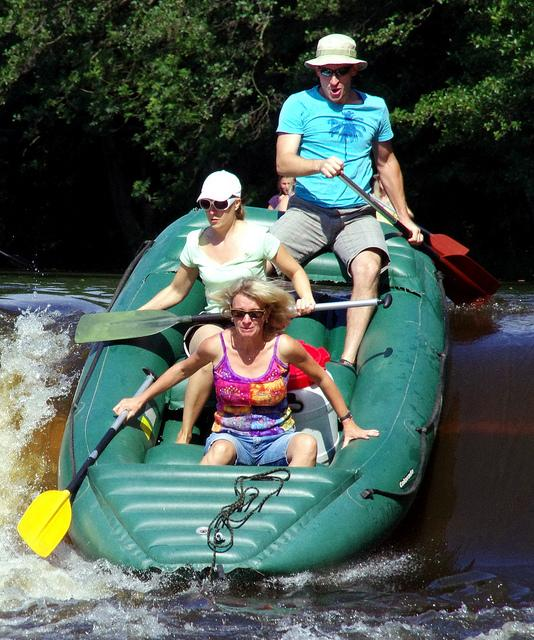What type of boat are they navigating the water on? raft 